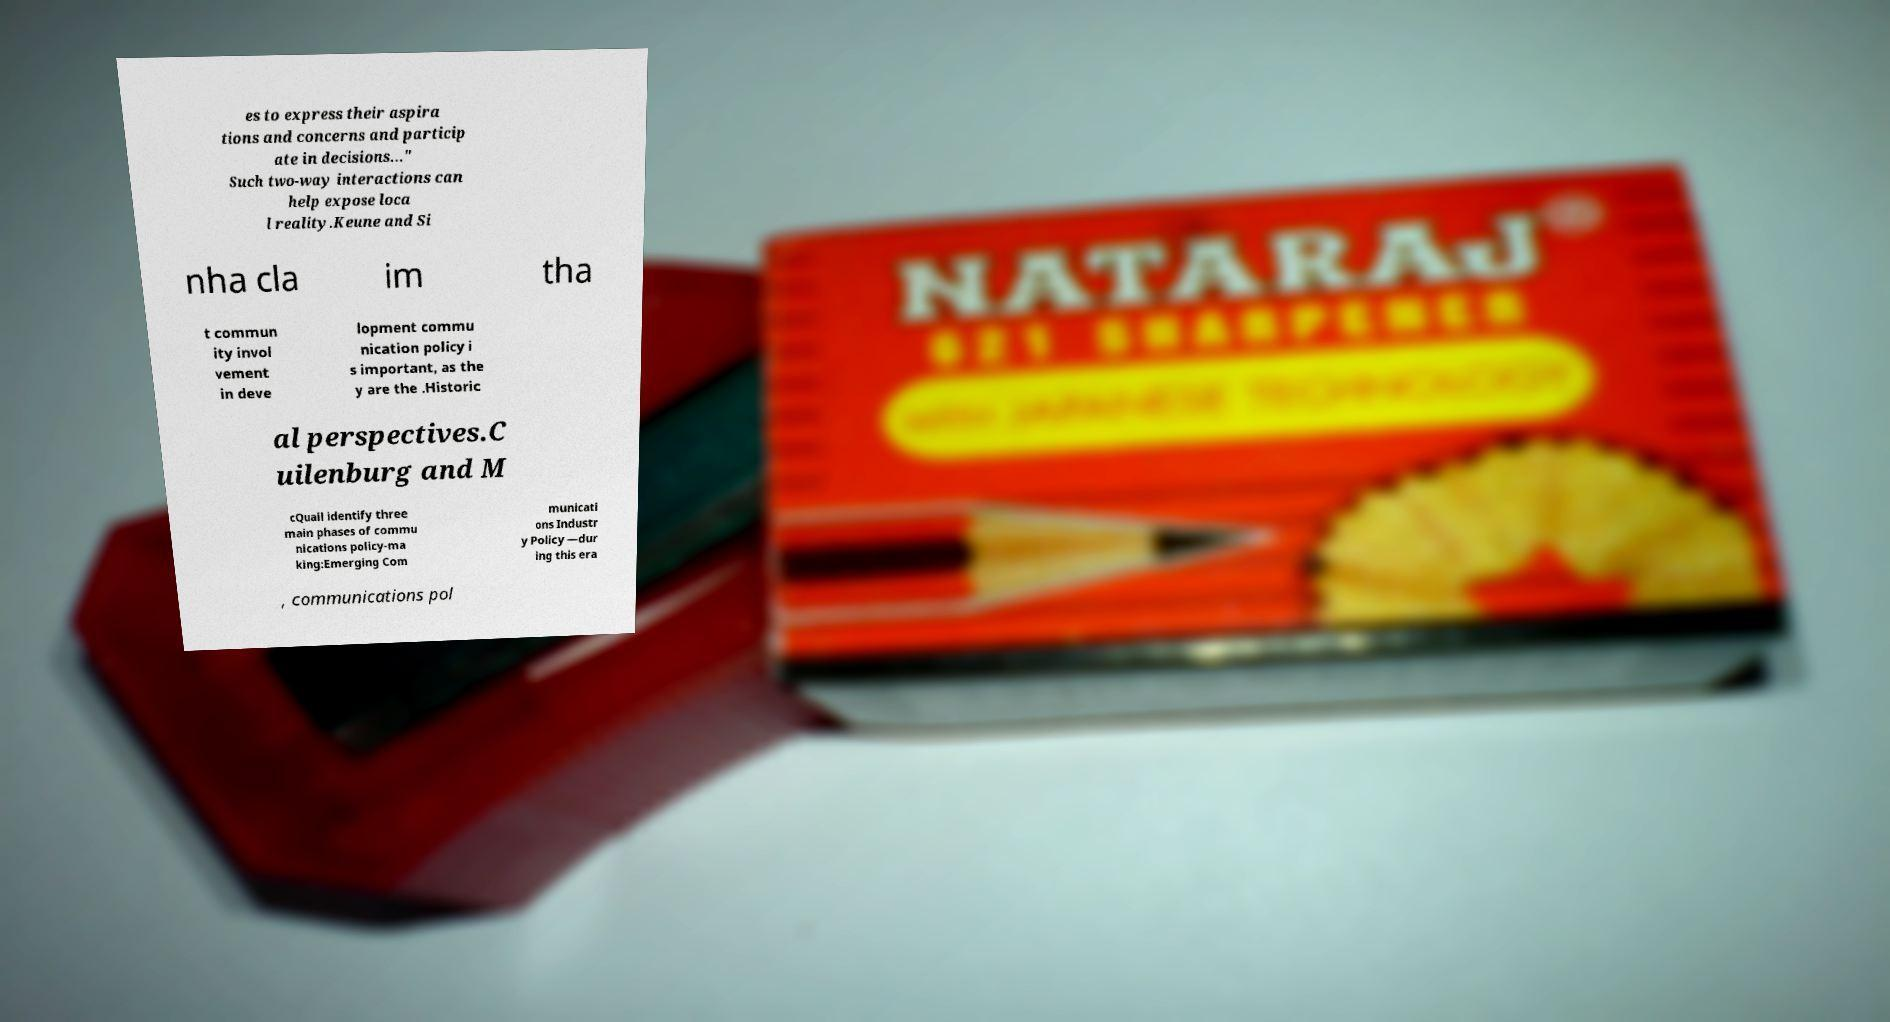There's text embedded in this image that I need extracted. Can you transcribe it verbatim? es to express their aspira tions and concerns and particip ate in decisions..." Such two-way interactions can help expose loca l reality.Keune and Si nha cla im tha t commun ity invol vement in deve lopment commu nication policy i s important, as the y are the .Historic al perspectives.C uilenburg and M cQuail identify three main phases of commu nications policy-ma king:Emerging Com municati ons Industr y Policy —dur ing this era , communications pol 